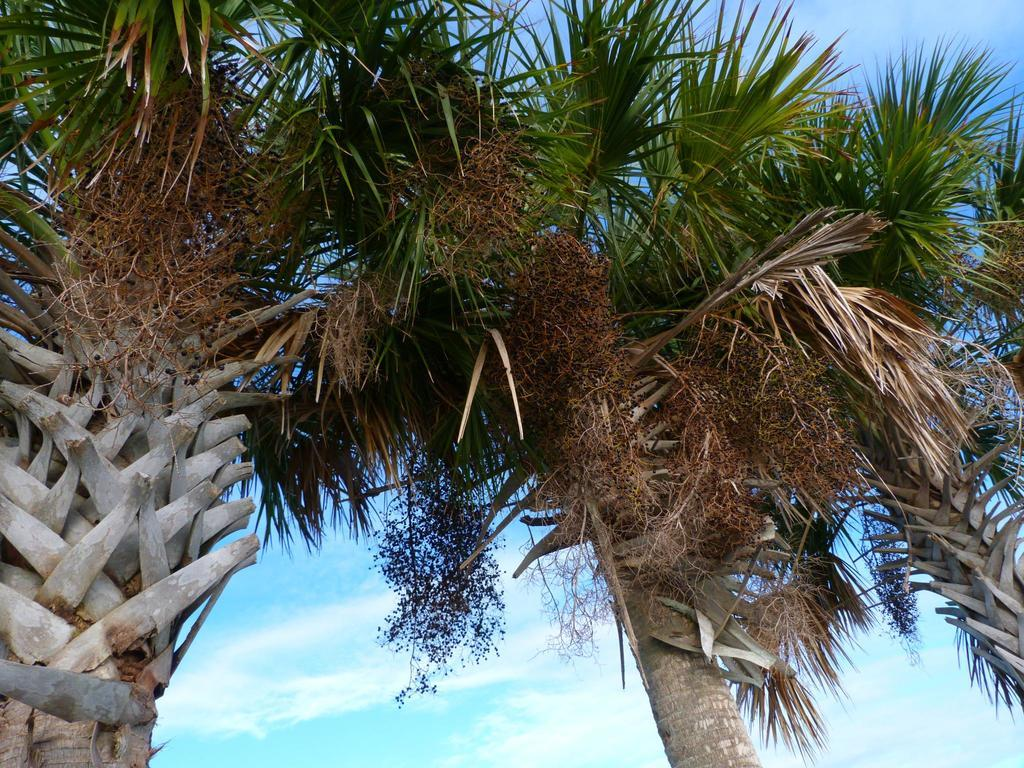What type of vegetation can be seen in the image? There are trees in the image. What is the condition of the sky in the image? The sky is cloudy in the image. What type of writing instrument is being used by the minister in the image? There is no minister or writing instrument present in the image. What body part is visible on the trees in the image? Trees do not have body parts, so this question cannot be answered. 